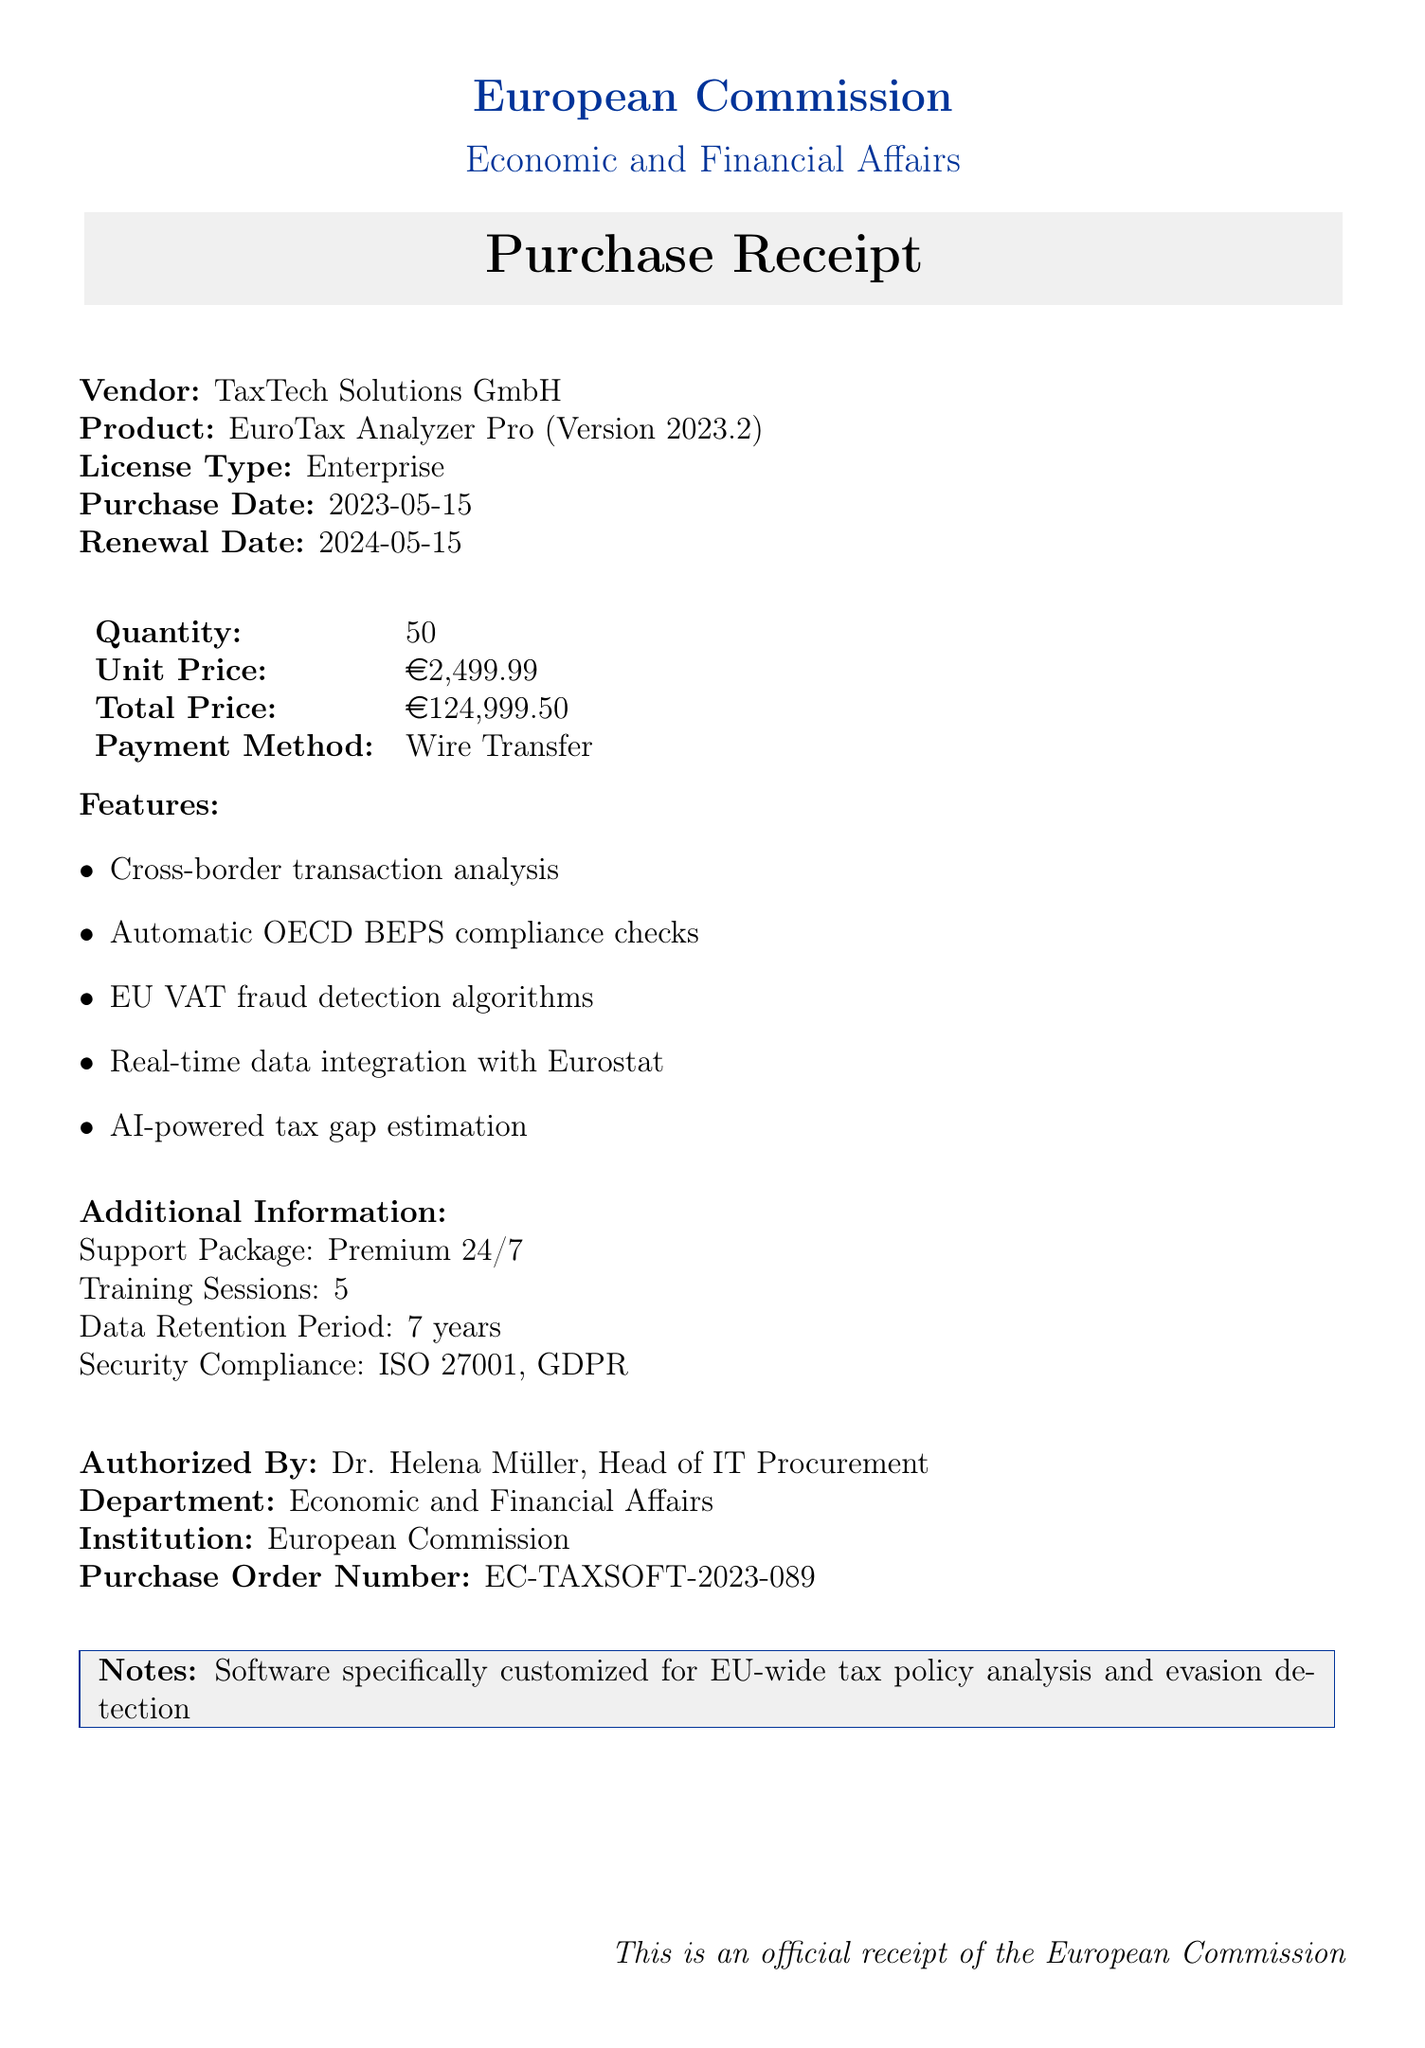What is the vendor's name? The document states the vendor is TaxTech Solutions GmbH.
Answer: TaxTech Solutions GmbH What is the total price of the purchase? The total price is specified as 124,999.50 EUR in the document.
Answer: 124,999.50 EUR What is the purchase date? The document lists the purchase date as May 15, 2023.
Answer: 2023-05-15 How many training sessions are included? The document mentions there are 5 training sessions provided.
Answer: 5 What type of license was purchased? The document specifies that the license type is Enterprise.
Answer: Enterprise What is the payment method used? The document indicates that the payment method was Wire Transfer.
Answer: Wire Transfer What is the security compliance stated in the document? The document mentions ISO 27001 and GDPR as security compliance.
Answer: ISO 27001, GDPR When is the renewal date of the software? The renewal date for the software is listed as May 15, 2024.
Answer: 2024-05-15 What department is responsible for the purchase? The document states that the department is Economic and Financial Affairs.
Answer: Economic and Financial Affairs 